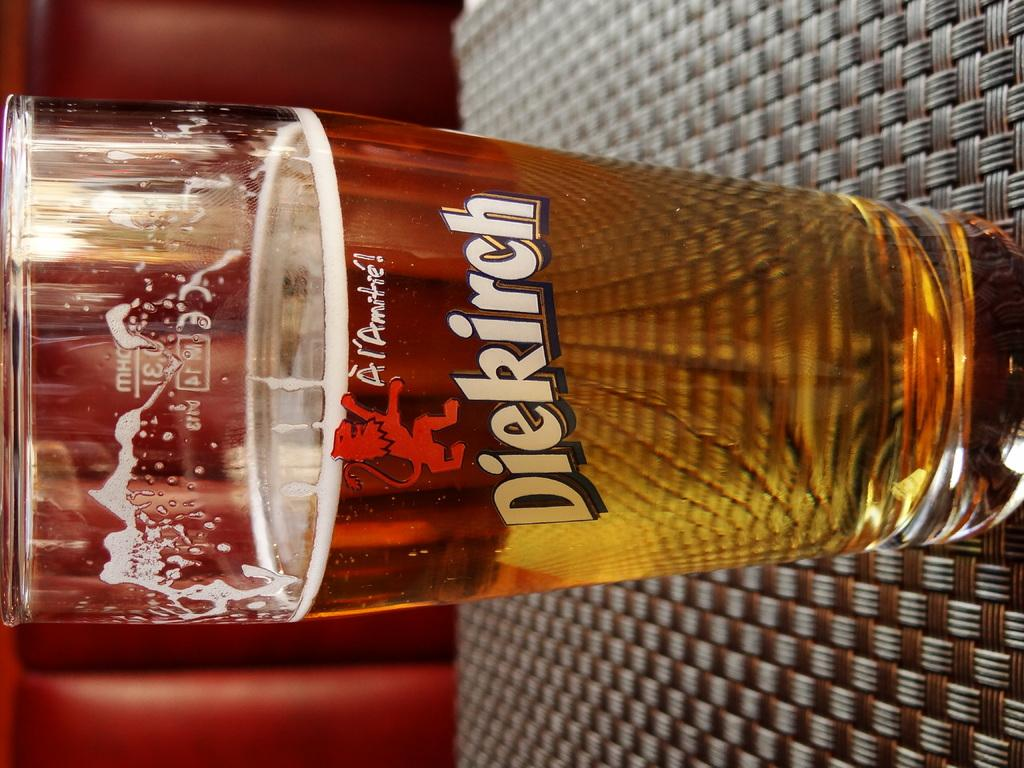<image>
Offer a succinct explanation of the picture presented. Glass of beer in a dierirch glass that is half way full 